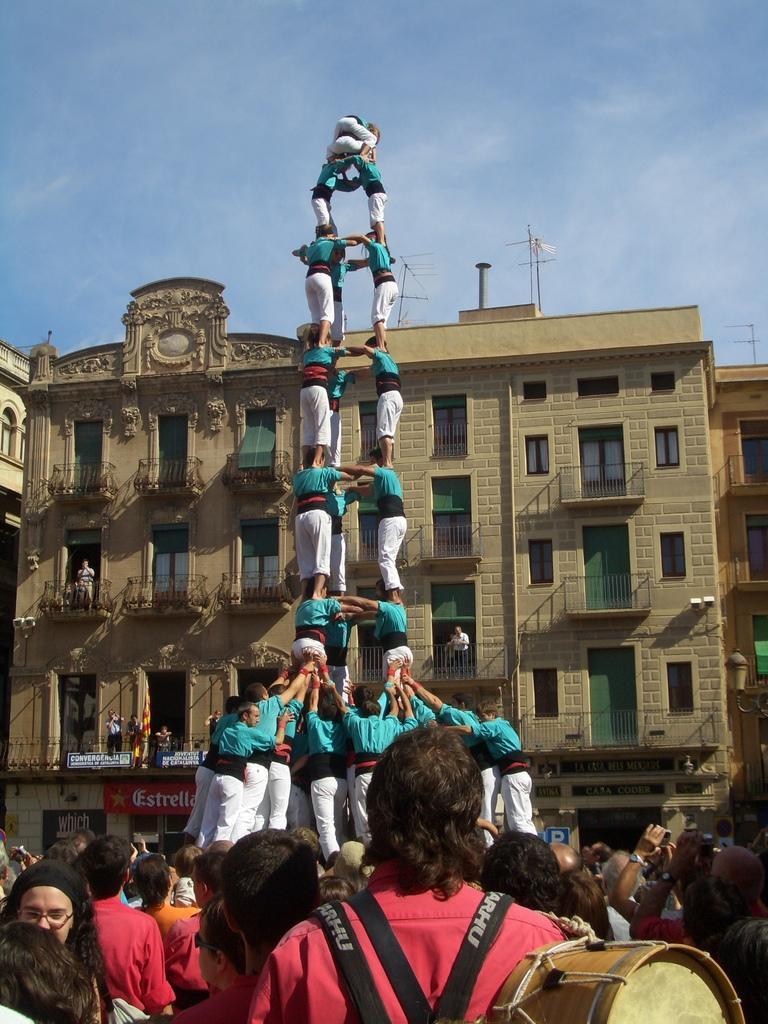How would you summarize this image in a sentence or two? There is a group of persons standing at the bottom of this image ,and there is a building in the background. There is a cloudy sky at the top of this image. 